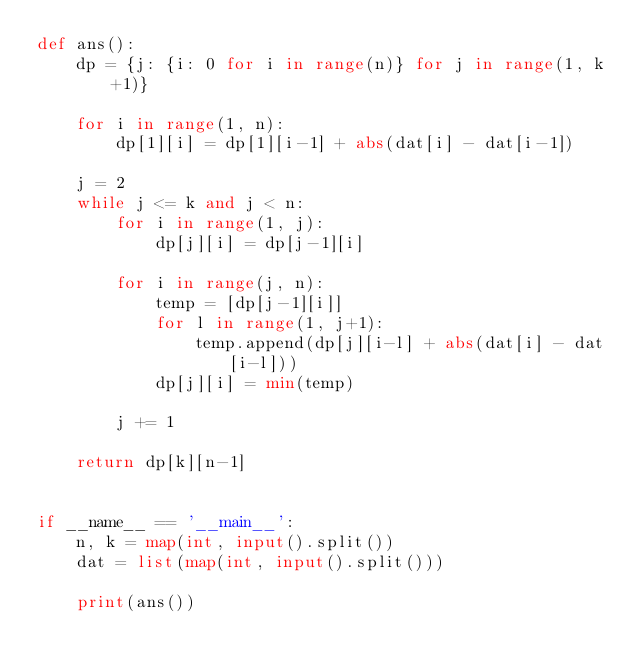<code> <loc_0><loc_0><loc_500><loc_500><_Python_>def ans():
    dp = {j: {i: 0 for i in range(n)} for j in range(1, k+1)}

    for i in range(1, n):
        dp[1][i] = dp[1][i-1] + abs(dat[i] - dat[i-1])

    j = 2
    while j <= k and j < n:
        for i in range(1, j):
            dp[j][i] = dp[j-1][i]

        for i in range(j, n):
            temp = [dp[j-1][i]]
            for l in range(1, j+1):
                temp.append(dp[j][i-l] + abs(dat[i] - dat[i-l]))
            dp[j][i] = min(temp)

        j += 1

    return dp[k][n-1]


if __name__ == '__main__':
    n, k = map(int, input().split())
    dat = list(map(int, input().split()))

    print(ans())

</code> 